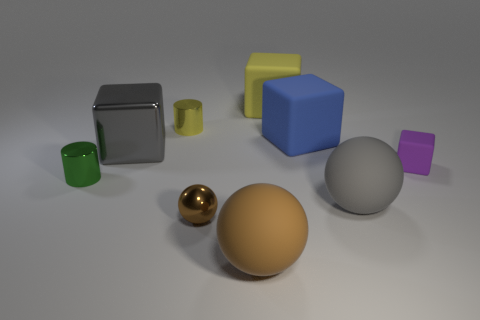Add 1 shiny balls. How many objects exist? 10 Subtract all blue blocks. How many blocks are left? 3 Subtract all cyan cubes. How many brown balls are left? 2 Subtract all blue blocks. How many blocks are left? 3 Subtract all red balls. Subtract all red cubes. How many balls are left? 3 Subtract all tiny cyan shiny objects. Subtract all brown objects. How many objects are left? 7 Add 8 green metallic things. How many green metallic things are left? 9 Add 2 large gray shiny objects. How many large gray shiny objects exist? 3 Subtract 0 purple spheres. How many objects are left? 9 Subtract all spheres. How many objects are left? 6 